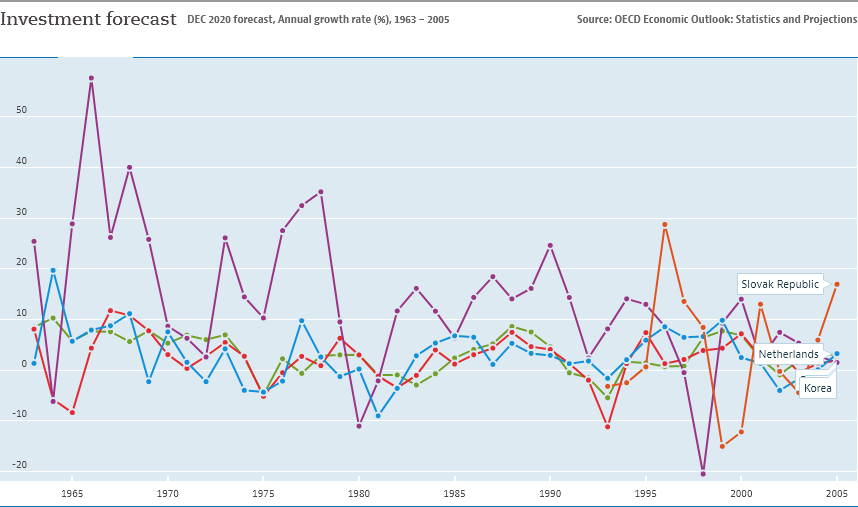List a handful of essential elements in this visual. The Slovak Republic is represented by the red line. The question is asking to find out how many data points are greater than or equal to 50. 